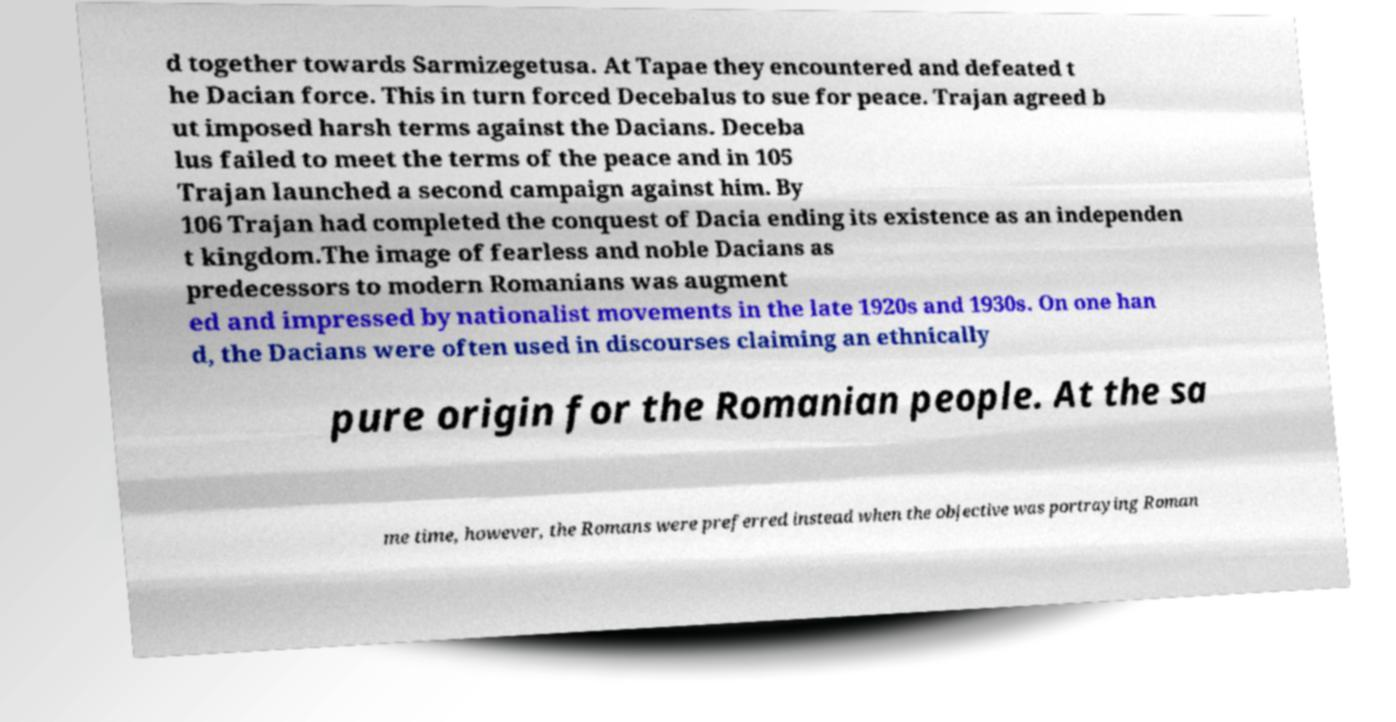What messages or text are displayed in this image? I need them in a readable, typed format. d together towards Sarmizegetusa. At Tapae they encountered and defeated t he Dacian force. This in turn forced Decebalus to sue for peace. Trajan agreed b ut imposed harsh terms against the Dacians. Deceba lus failed to meet the terms of the peace and in 105 Trajan launched a second campaign against him. By 106 Trajan had completed the conquest of Dacia ending its existence as an independen t kingdom.The image of fearless and noble Dacians as predecessors to modern Romanians was augment ed and impressed by nationalist movements in the late 1920s and 1930s. On one han d, the Dacians were often used in discourses claiming an ethnically pure origin for the Romanian people. At the sa me time, however, the Romans were preferred instead when the objective was portraying Roman 